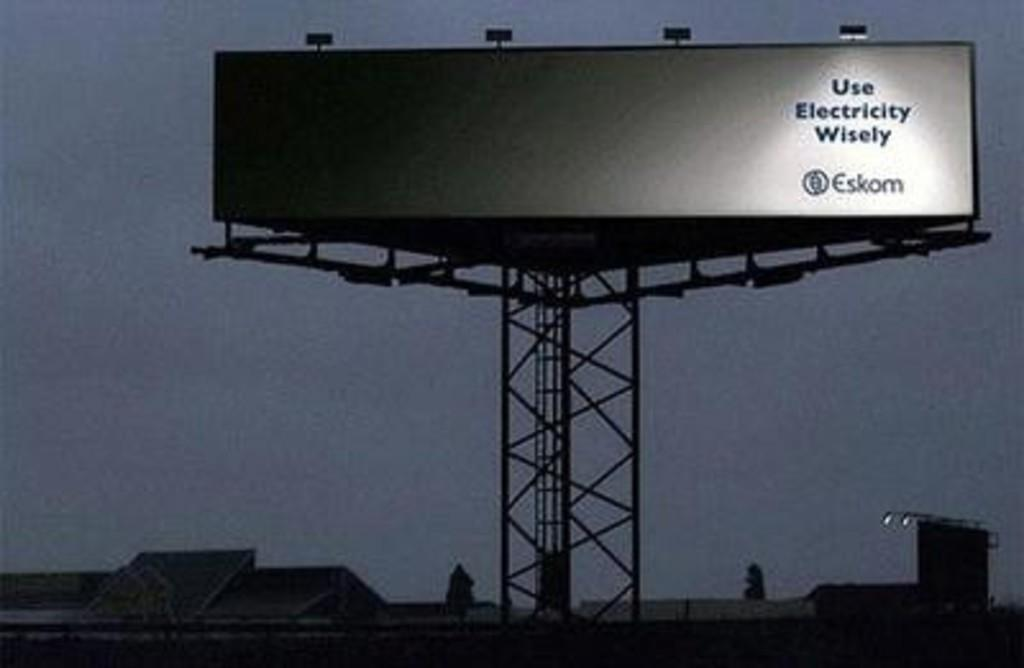<image>
Relay a brief, clear account of the picture shown. A large white outdoor billboard stating Use Electricity Wisely. 